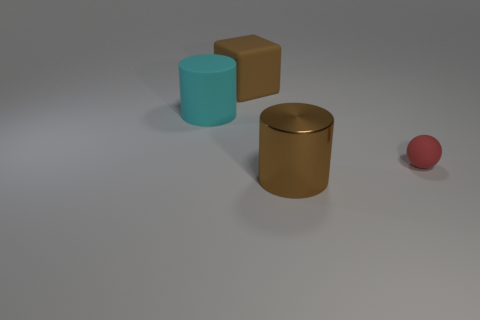What number of other things are there of the same material as the cyan object
Offer a very short reply. 2. Are there any tiny red cylinders?
Ensure brevity in your answer.  No. Is the material of the brown thing behind the large cyan thing the same as the brown cylinder?
Ensure brevity in your answer.  No. There is a brown thing that is the same shape as the cyan matte thing; what is it made of?
Keep it short and to the point. Metal. What material is the large object that is the same color as the rubber block?
Keep it short and to the point. Metal. Are there fewer cyan matte cylinders than gray rubber cylinders?
Offer a very short reply. No. There is a big cylinder that is to the left of the big shiny cylinder; is it the same color as the cube?
Offer a very short reply. No. There is a big cylinder that is made of the same material as the big brown cube; what is its color?
Provide a succinct answer. Cyan. Do the brown rubber object and the cyan matte object have the same size?
Offer a very short reply. Yes. What is the small ball made of?
Your response must be concise. Rubber. 